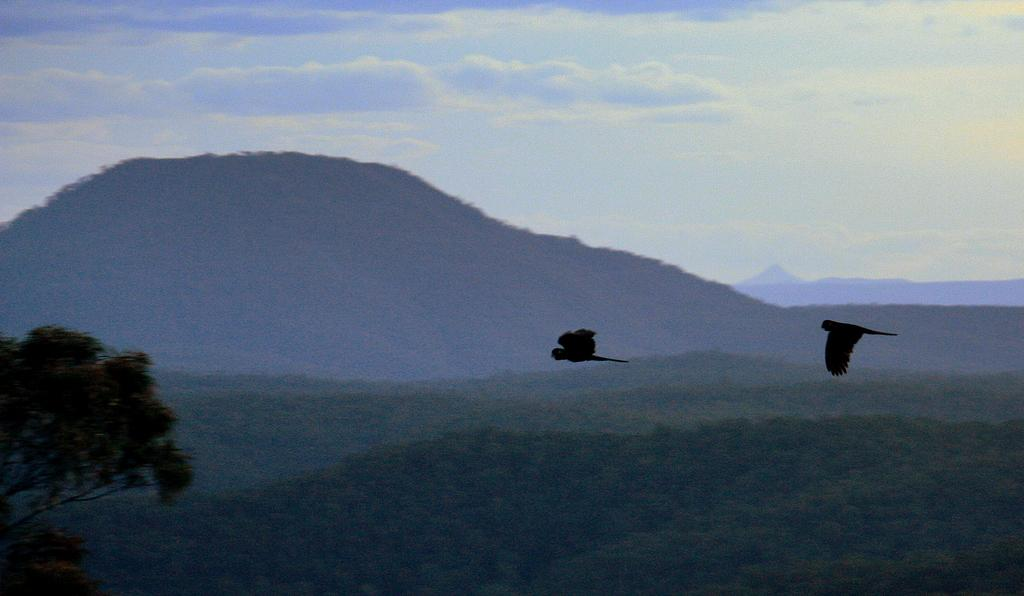What type of natural formation can be seen in the image? There are mountains in the image. What else can be seen on the ground in the image? There are trees on the ground in the image. What animals are present in the image? Two birds are flying in the image. What is visible at the top of the image? The sky is visible at the top of the image. What is the condition of the sky in the image? The sky is cloudy in the image. Where is the desk located in the image? There is no desk present in the image. Is there a quilt covering the mountains in the image? There is no quilt present in the image. 